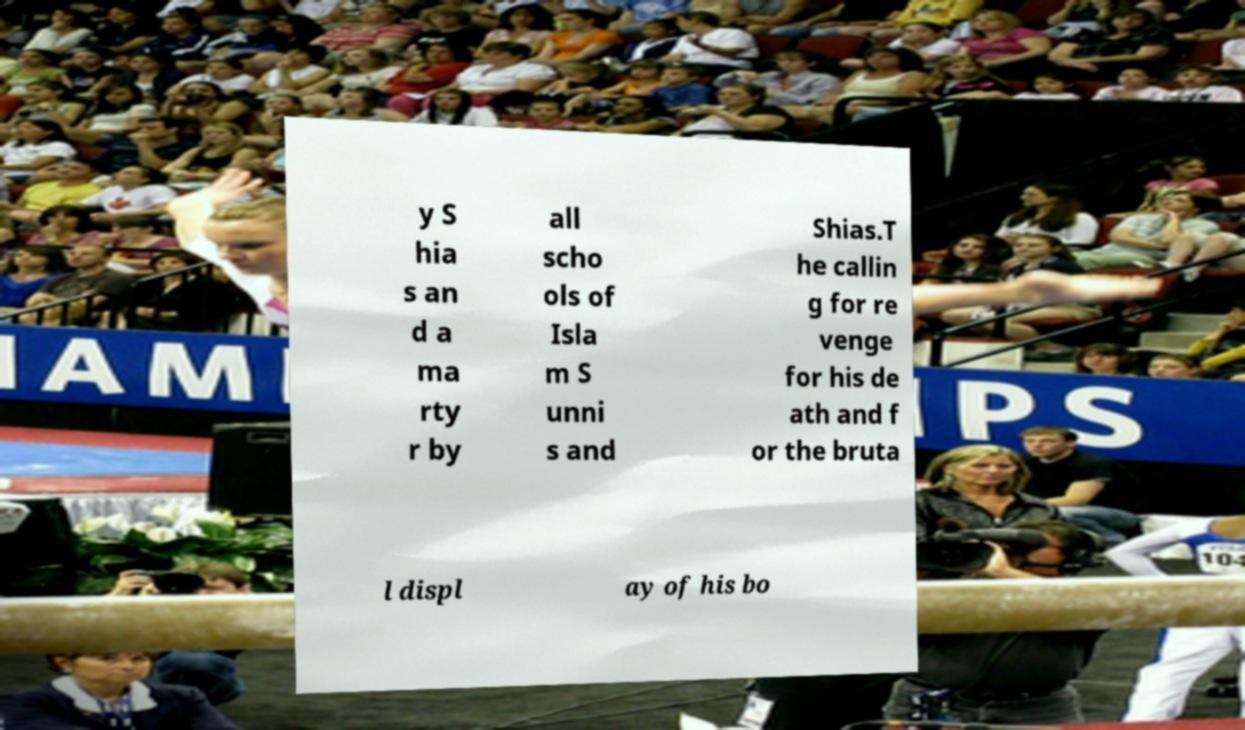Can you read and provide the text displayed in the image?This photo seems to have some interesting text. Can you extract and type it out for me? y S hia s an d a ma rty r by all scho ols of Isla m S unni s and Shias.T he callin g for re venge for his de ath and f or the bruta l displ ay of his bo 